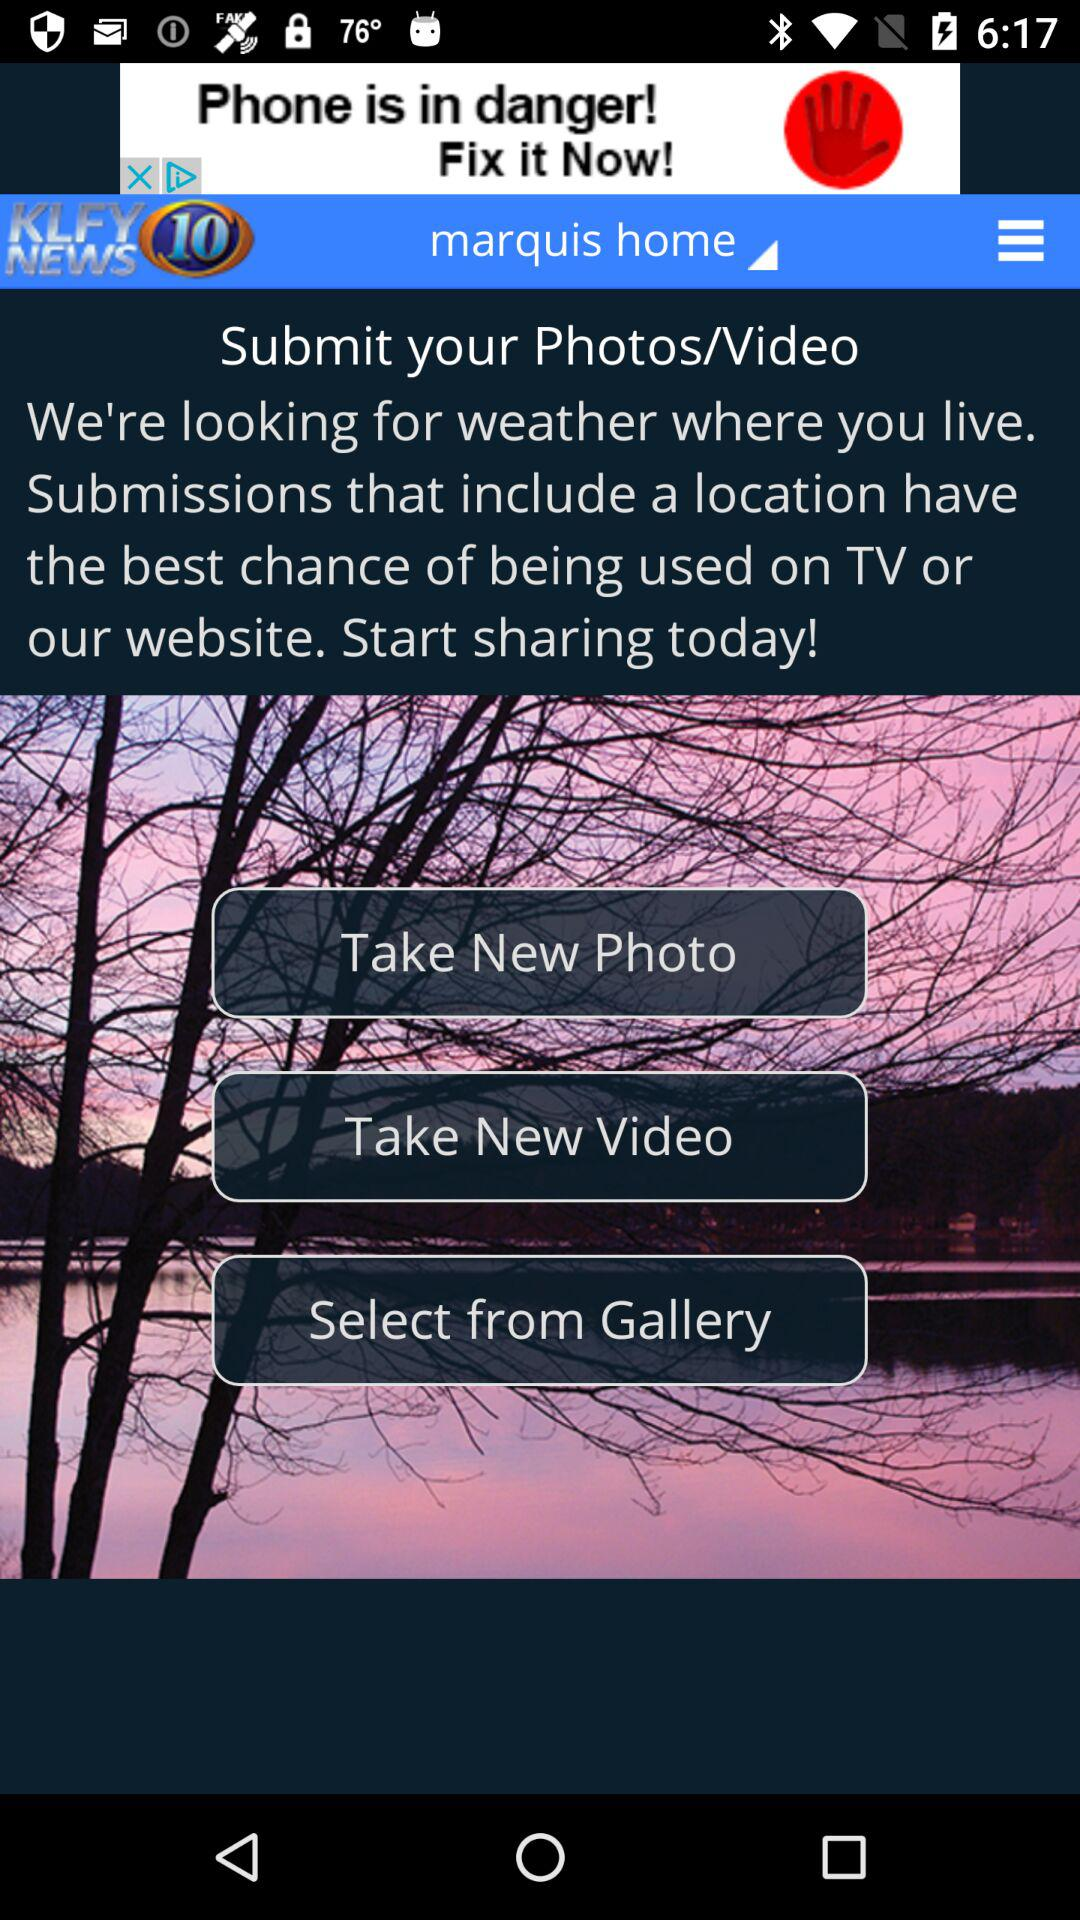Which options are given for submitting photos or videos? The given options are "Take New Photo", "Take New Video" and "Select from Gallery". 